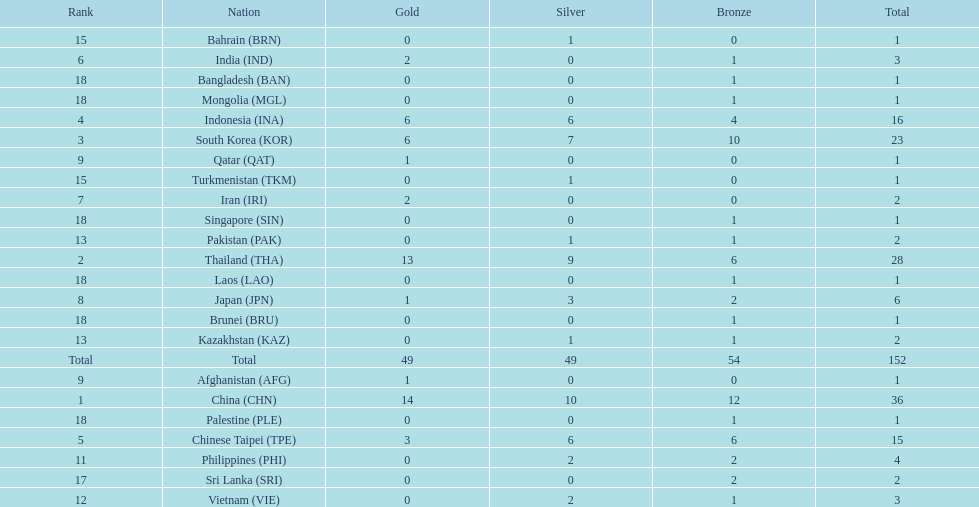How many nations won no silver medals at all? 11. 